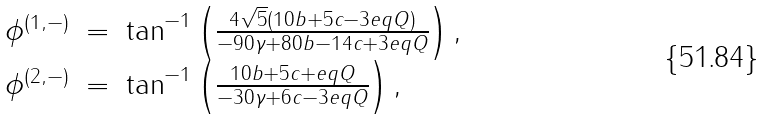Convert formula to latex. <formula><loc_0><loc_0><loc_500><loc_500>\begin{array} { l l l } \phi ^ { ( 1 , - ) } & = & \tan ^ { - 1 } \left ( \frac { 4 \sqrt { 5 } ( 1 0 b + 5 c - 3 e q Q ) } { - 9 0 \gamma + 8 0 b - 1 4 c + 3 e q Q } \right ) , \\ \phi ^ { ( 2 , - ) } & = & \tan ^ { - 1 } \left ( \frac { 1 0 b + 5 c + e q Q } { - 3 0 \gamma + 6 c - 3 e q Q } \right ) , \end{array}</formula> 